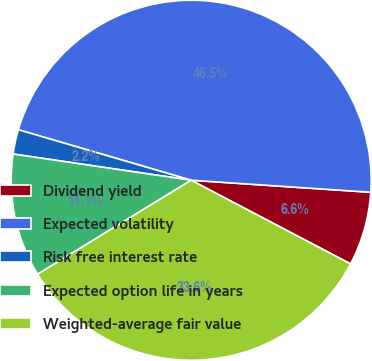<chart> <loc_0><loc_0><loc_500><loc_500><pie_chart><fcel>Dividend yield<fcel>Expected volatility<fcel>Risk free interest rate<fcel>Expected option life in years<fcel>Weighted-average fair value<nl><fcel>6.63%<fcel>46.54%<fcel>2.2%<fcel>11.07%<fcel>33.56%<nl></chart> 